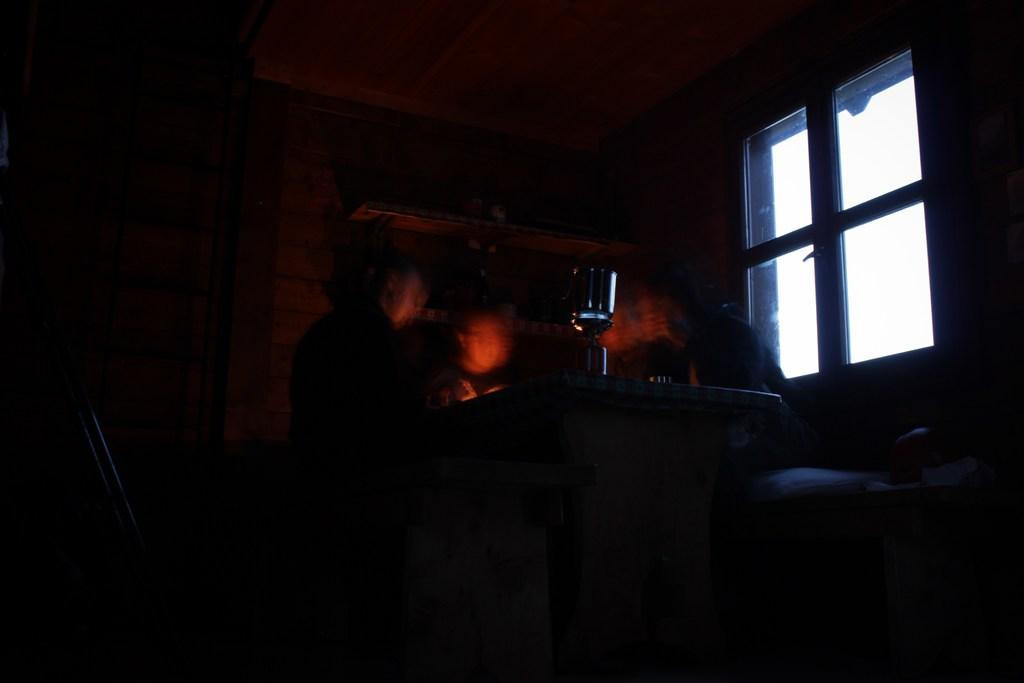How many people are in the image? There are persons standing in the image. What can be seen in the image besides the people? There is a window in the image. What is the color of the background in the image? The background of the image is dark. What type of growth can be seen on the wire in the image? There is no wire or growth present in the image. 